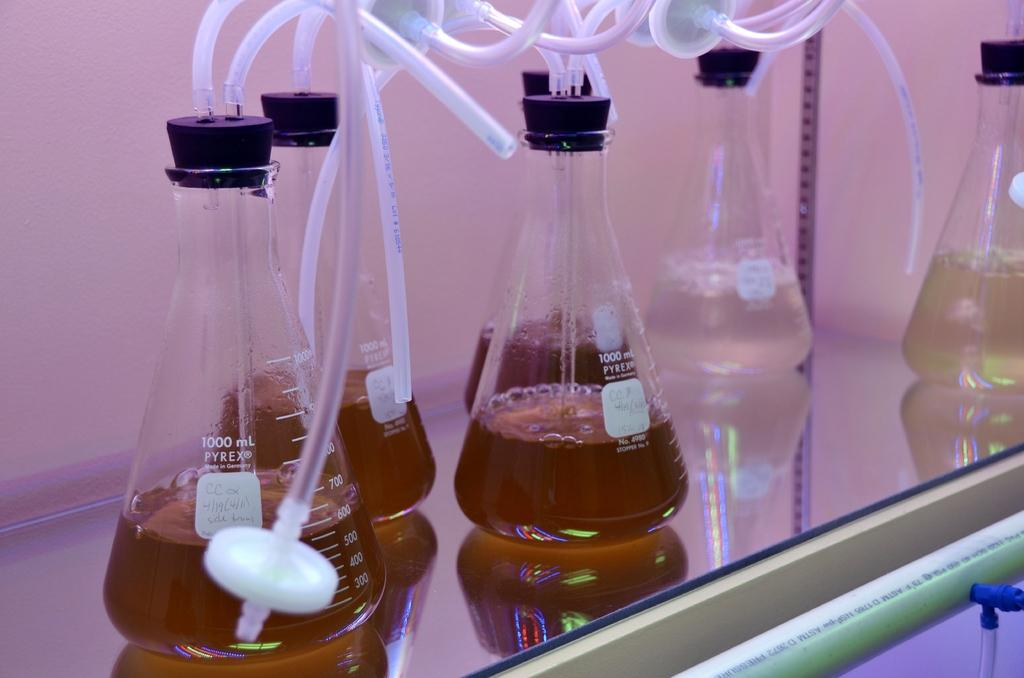<image>
Render a clear and concise summary of the photo. Several 1000 mL beakers by PYREX sit on a glass shelf. 